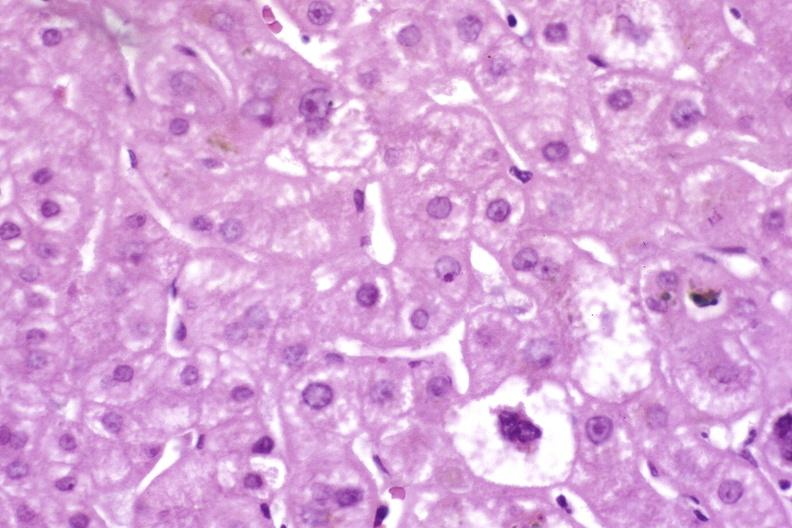does this image show resolving acute rejection?
Answer the question using a single word or phrase. Yes 